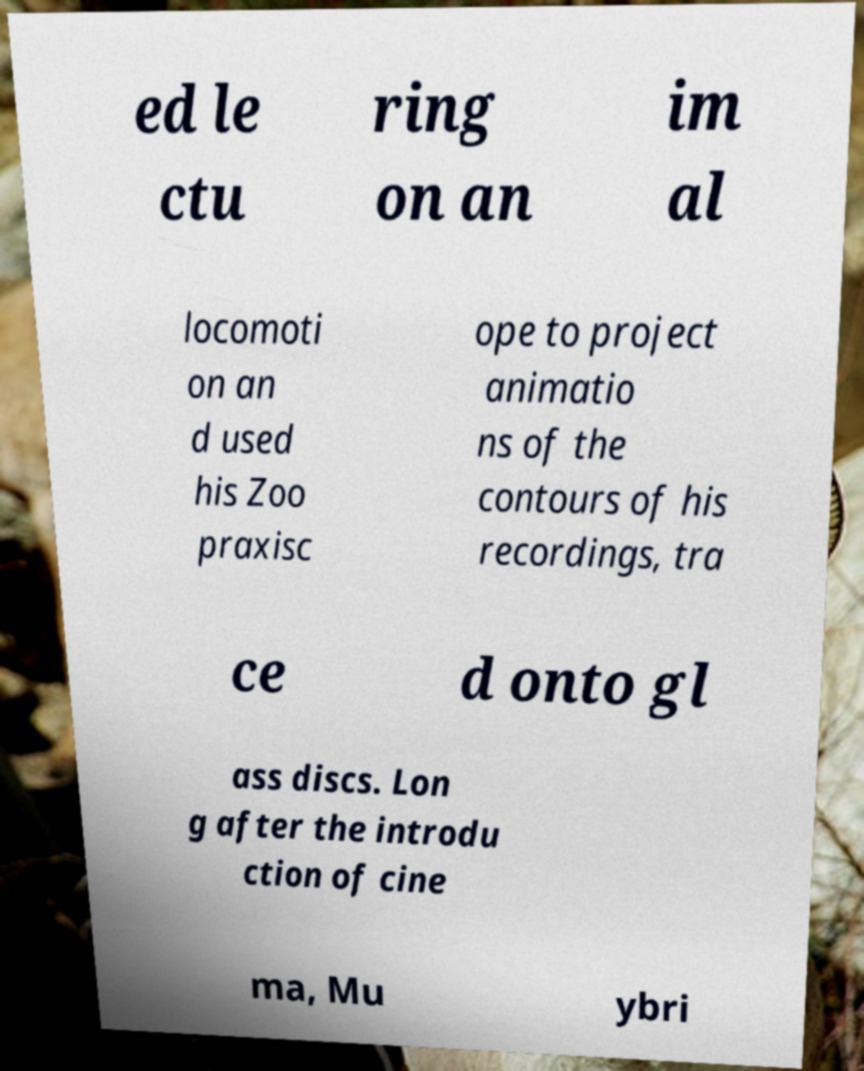Please read and relay the text visible in this image. What does it say? ed le ctu ring on an im al locomoti on an d used his Zoo praxisc ope to project animatio ns of the contours of his recordings, tra ce d onto gl ass discs. Lon g after the introdu ction of cine ma, Mu ybri 